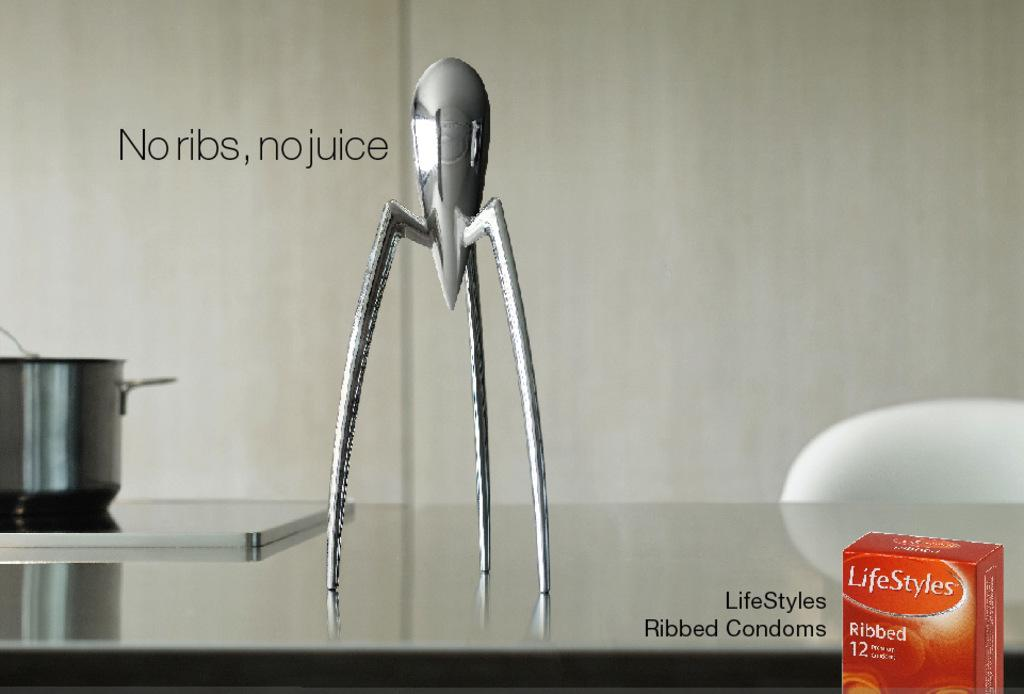<image>
Describe the image concisely. An advertisement for a box of LifeStyles Ribbed Condoms 